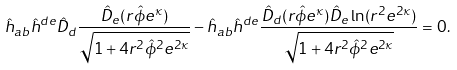Convert formula to latex. <formula><loc_0><loc_0><loc_500><loc_500>\hat { h } _ { a b } \hat { h } ^ { d e } \hat { D } _ { d } \frac { \hat { D } _ { e } ( r \hat { \phi } e ^ { \kappa } ) } { \sqrt { 1 + 4 r ^ { 2 } \hat { \phi } ^ { 2 } e ^ { 2 \kappa } } } - \hat { h } _ { a b } \hat { h } ^ { d e } \frac { \hat { D } _ { d } ( r \hat { \phi } e ^ { \kappa } ) \hat { D } _ { e } \ln ( r ^ { 2 } e ^ { 2 \kappa } ) } { \sqrt { 1 + 4 r ^ { 2 } \hat { \phi } ^ { 2 } e ^ { 2 \kappa } } } = 0 .</formula> 